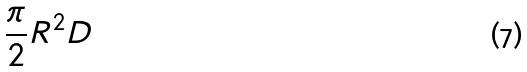Convert formula to latex. <formula><loc_0><loc_0><loc_500><loc_500>\frac { \pi } { 2 } R ^ { 2 } D</formula> 